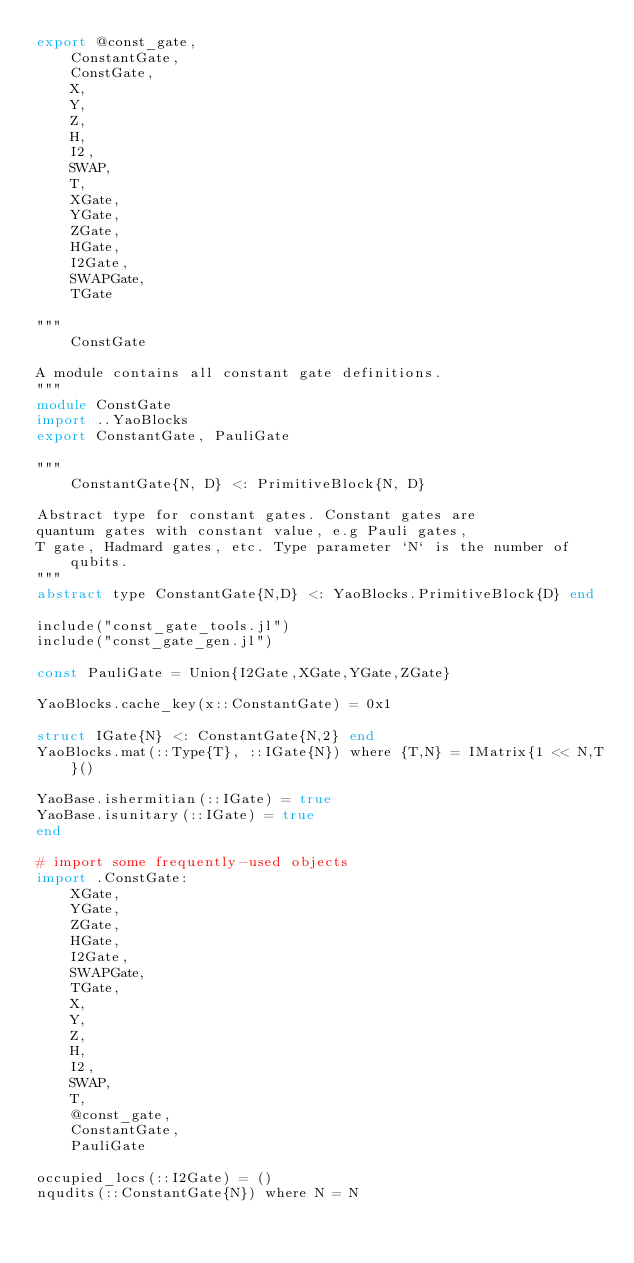Convert code to text. <code><loc_0><loc_0><loc_500><loc_500><_Julia_>export @const_gate,
    ConstantGate,
    ConstGate,
    X,
    Y,
    Z,
    H,
    I2,
    SWAP,
    T,
    XGate,
    YGate,
    ZGate,
    HGate,
    I2Gate,
    SWAPGate,
    TGate

"""
    ConstGate

A module contains all constant gate definitions.
"""
module ConstGate
import ..YaoBlocks
export ConstantGate, PauliGate

"""
    ConstantGate{N, D} <: PrimitiveBlock{N, D}

Abstract type for constant gates. Constant gates are
quantum gates with constant value, e.g Pauli gates,
T gate, Hadmard gates, etc. Type parameter `N` is the number of qubits.
"""
abstract type ConstantGate{N,D} <: YaoBlocks.PrimitiveBlock{D} end

include("const_gate_tools.jl")
include("const_gate_gen.jl")

const PauliGate = Union{I2Gate,XGate,YGate,ZGate}

YaoBlocks.cache_key(x::ConstantGate) = 0x1

struct IGate{N} <: ConstantGate{N,2} end
YaoBlocks.mat(::Type{T}, ::IGate{N}) where {T,N} = IMatrix{1 << N,T}()

YaoBase.ishermitian(::IGate) = true
YaoBase.isunitary(::IGate) = true
end

# import some frequently-used objects
import .ConstGate:
    XGate,
    YGate,
    ZGate,
    HGate,
    I2Gate,
    SWAPGate,
    TGate,
    X,
    Y,
    Z,
    H,
    I2,
    SWAP,
    T,
    @const_gate,
    ConstantGate,
    PauliGate

occupied_locs(::I2Gate) = ()
nqudits(::ConstantGate{N}) where N = N
</code> 